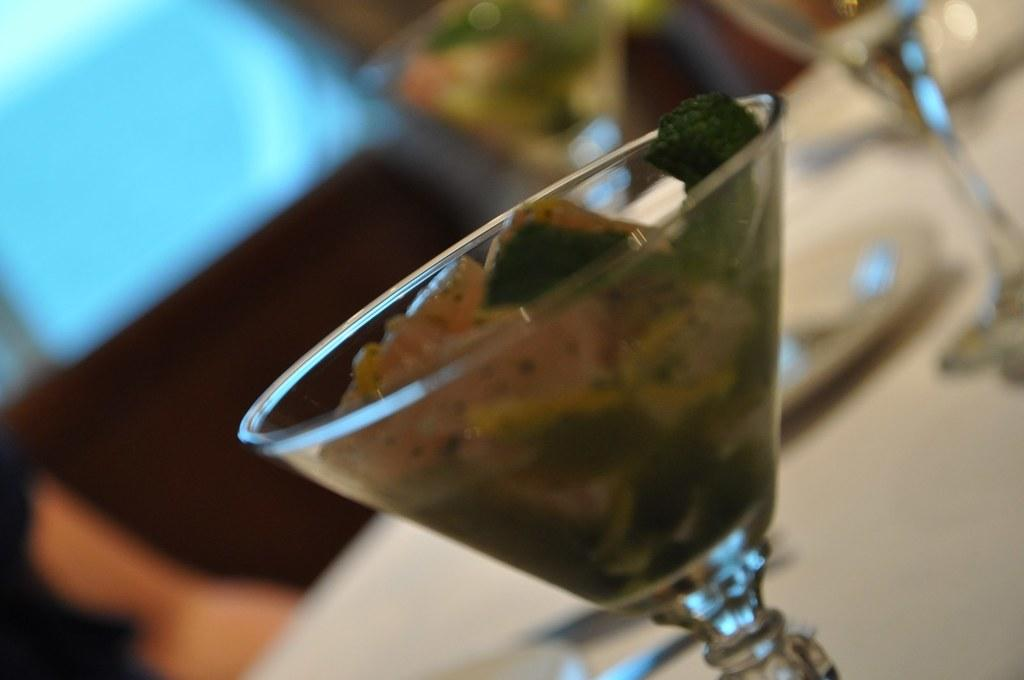What is inside the glasses that are visible in the image? There are glasses containing food in the image. What other item can be seen on the table in the image? There is a plate in the image. Where are the glasses and plate located in the image? The glasses and plate are placed on a table. Whose hand is visible at the bottom left of the image? There is a person's hand visible at the bottom left of the image. What type of notebook is being used by the person in the image? There is no notebook present in the image; only a person's hand is visible at the bottom left. 